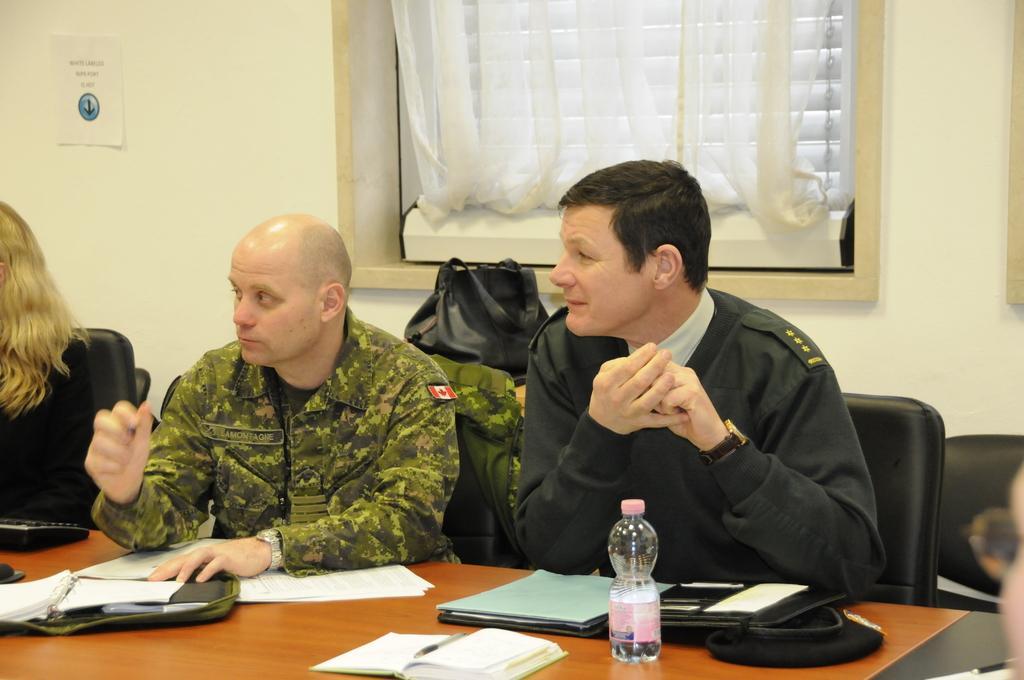How would you summarize this image in a sentence or two? In this picture there are two men sitting and another woman sitting beside them both of them are watching to the left and they have a table in front of them with some papers a water bottle of file or notebook with pen accept and in the background there is a wall with paper and pasted on it and is also window with a curtain. 